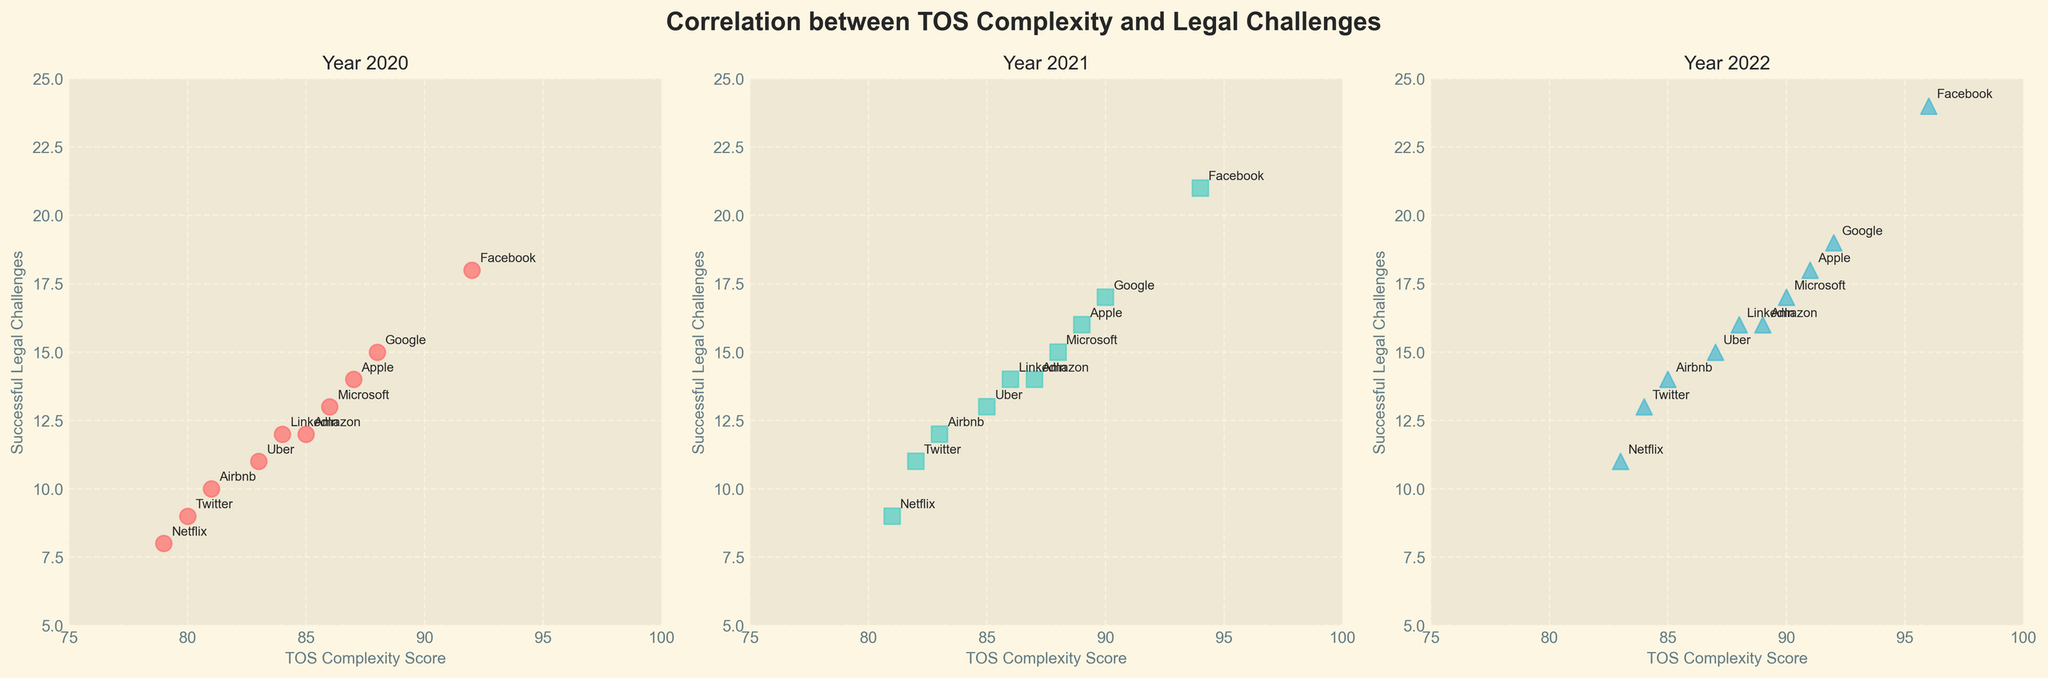Which website had the highest number of successful legal challenges in 2022? Observe the scatter plot for the year 2022. Identify the data point that has the highest y-value (successful legal challenges). Look at the label of this data point.
Answer: Facebook How does the TOS complexity score for Facebook change from 2020 to 2022? Find Facebook's TOS complexity score in each of the three subplots. Note the scores and compare them across the years 2020, 2021, and 2022.
Answer: Increased from 92 to 96 Which year had the smallest range of successful legal challenges? For each year, identify the maximum and minimum values on the y-axis. Calculate the range by subtracting the minimum from the maximum. Compare the ranges across the years.
Answer: 2020 Did Uber have more successful legal challenges in 2020 or 2022? Locate the data points for Uber in the 2020 and 2022 subplots. Read the y-values for each of these points and compare them.
Answer: 2022 Which website experienced the largest increase in successful legal challenges from 2020 to 2022? For each website, calculate the difference in successful legal challenges between 2022 and 2020. Identify the website with the largest positive difference.
Answer: Facebook In 2021, which website had the lowest TOS complexity score? Identify the data point with the lowest x-value (TOS complexity score) in the 2021 subplot. Check the label of this data point.
Answer: Netflix What is the average TOS complexity score for all websites in 2022? Sum up all the TOS complexity scores for the 2022 subplot and divide by the number of websites (10). Do the arithmetic: (89 + 96 + 92 + 84 + 91 + 90 + 83 + 87 + 85 + 88) / 10.
Answer: 88.5 Compare the successful legal challenges between Airbnb and Uber in 2021. Which had more? Find the data points for Airbnb and Uber in the 2021 subplot. Compare their y-values (successful legal challenges).
Answer: Uber Was there a correlation between TOS complexity and successful legal challenges in 2020? Observe the scatter plot for the year 2020. Check if the points show a trend (positive, negative, or none) as TOS complexity scores increase.
Answer: Positive correlation Identify the trend in TOS complexity scores for Microsoft from 2020 to 2022. Note Microsoft's TOS complexity score in each subplot and observe the changes over the years from 2020 to 2022.
Answer: Increased from 86 to 90 